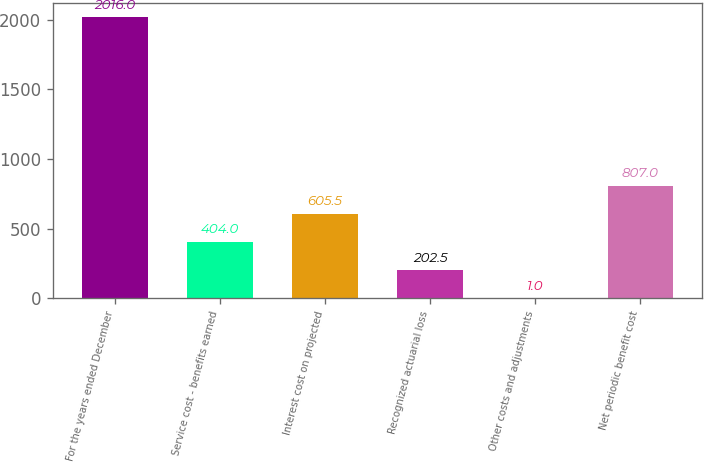Convert chart to OTSL. <chart><loc_0><loc_0><loc_500><loc_500><bar_chart><fcel>For the years ended December<fcel>Service cost - benefits earned<fcel>Interest cost on projected<fcel>Recognized actuarial loss<fcel>Other costs and adjustments<fcel>Net periodic benefit cost<nl><fcel>2016<fcel>404<fcel>605.5<fcel>202.5<fcel>1<fcel>807<nl></chart> 